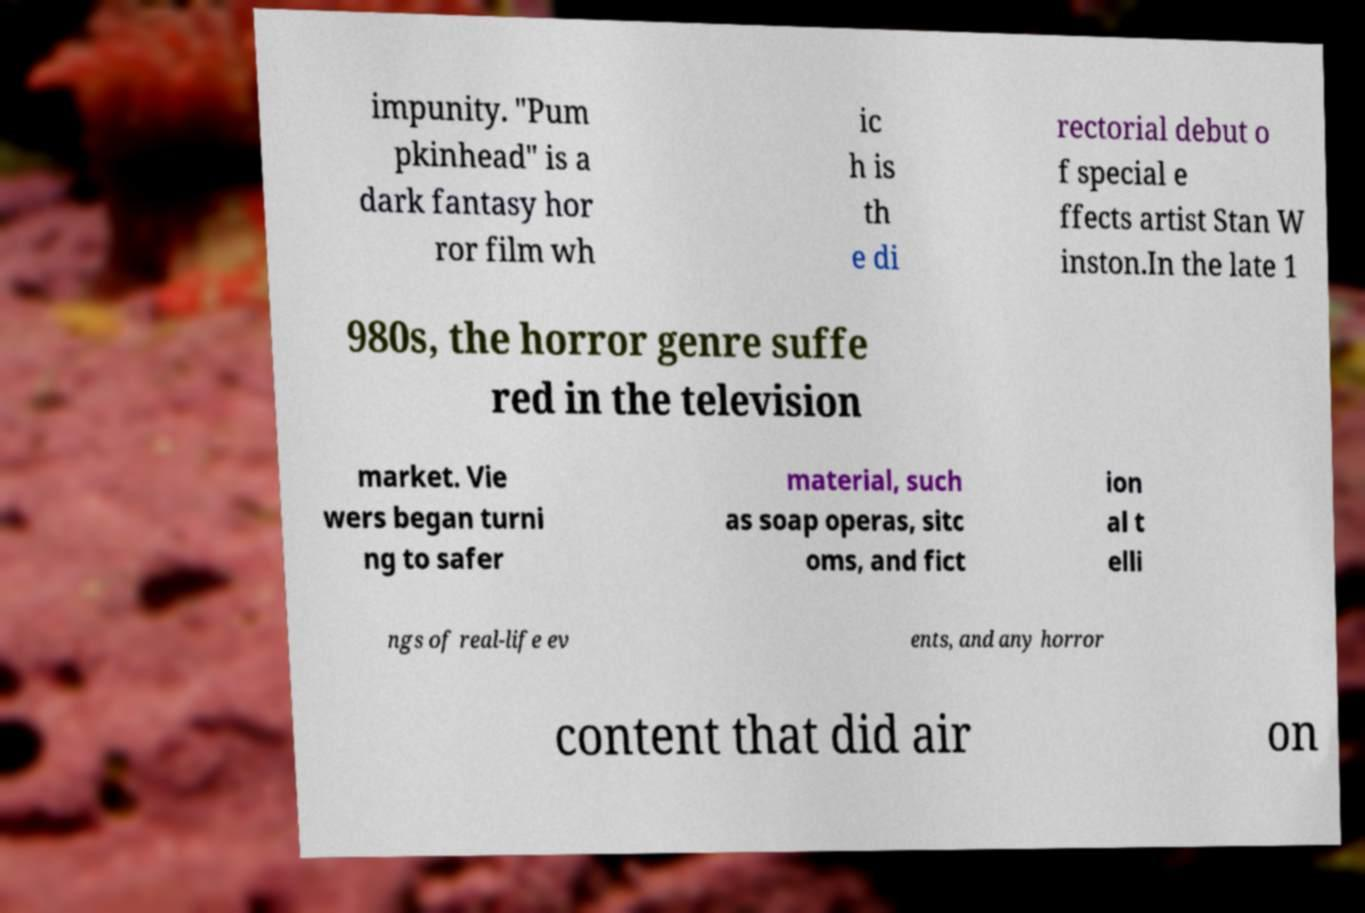Could you assist in decoding the text presented in this image and type it out clearly? impunity. "Pum pkinhead" is a dark fantasy hor ror film wh ic h is th e di rectorial debut o f special e ffects artist Stan W inston.In the late 1 980s, the horror genre suffe red in the television market. Vie wers began turni ng to safer material, such as soap operas, sitc oms, and fict ion al t elli ngs of real-life ev ents, and any horror content that did air on 